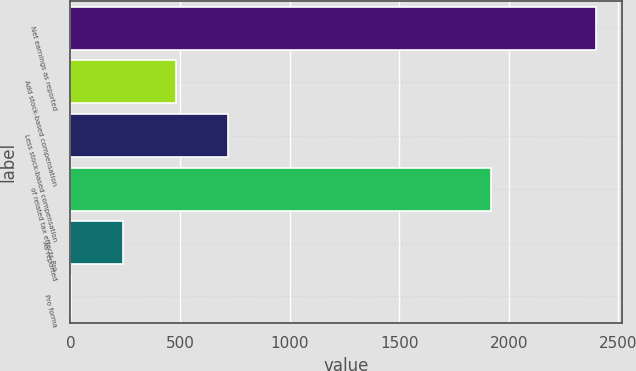Convert chart. <chart><loc_0><loc_0><loc_500><loc_500><bar_chart><fcel>Net earnings as reported<fcel>Add stock-based compensation<fcel>Less stock-based compensation<fcel>of related tax effects Pro<fcel>As reported<fcel>Pro forma<nl><fcel>2398<fcel>480.13<fcel>719.86<fcel>1921<fcel>240.4<fcel>0.67<nl></chart> 